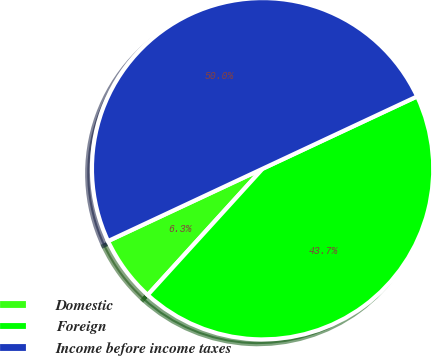<chart> <loc_0><loc_0><loc_500><loc_500><pie_chart><fcel>Domestic<fcel>Foreign<fcel>Income before income taxes<nl><fcel>6.28%<fcel>43.72%<fcel>50.0%<nl></chart> 